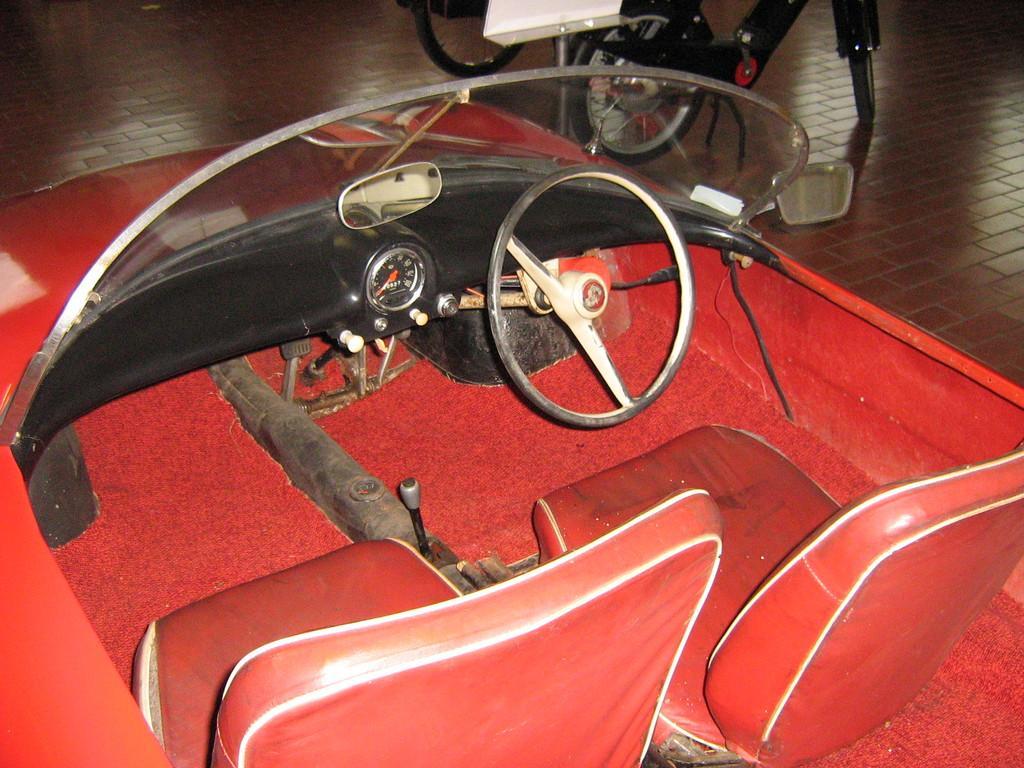Please provide a concise description of this image. In this image I can see a red colour vehicle and I can also see few red colour seats, mirrors, steering, speedometer and in background I can see few other vehicles. 